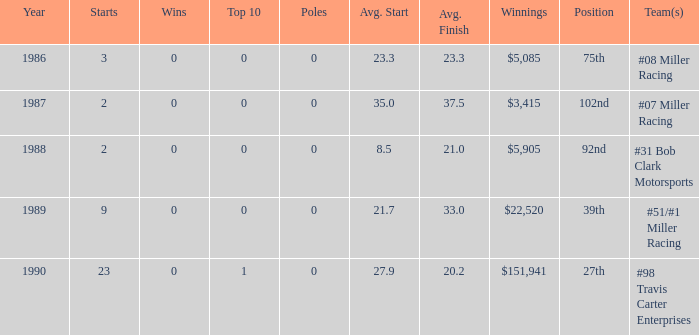3? #08 Miller Racing. 